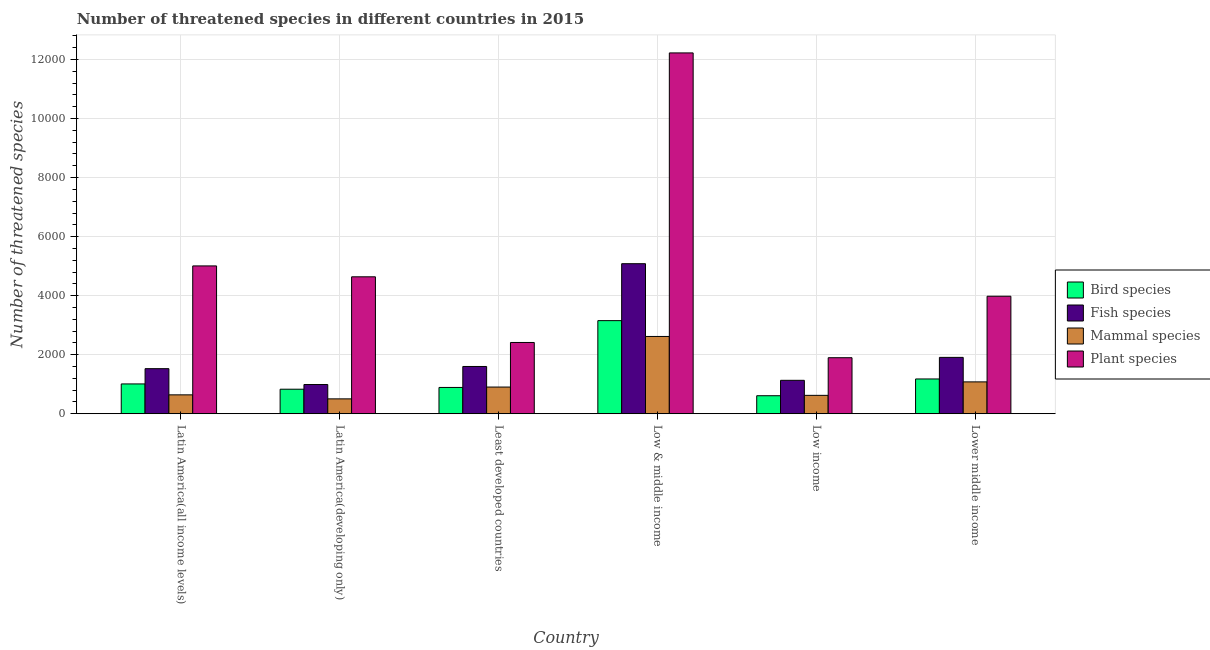How many groups of bars are there?
Your answer should be very brief. 6. Are the number of bars on each tick of the X-axis equal?
Your answer should be compact. Yes. What is the label of the 3rd group of bars from the left?
Keep it short and to the point. Least developed countries. What is the number of threatened plant species in Low & middle income?
Ensure brevity in your answer.  1.22e+04. Across all countries, what is the maximum number of threatened mammal species?
Provide a short and direct response. 2618. Across all countries, what is the minimum number of threatened mammal species?
Ensure brevity in your answer.  504. In which country was the number of threatened fish species maximum?
Your answer should be compact. Low & middle income. In which country was the number of threatened fish species minimum?
Give a very brief answer. Latin America(developing only). What is the total number of threatened fish species in the graph?
Offer a very short reply. 1.22e+04. What is the difference between the number of threatened bird species in Latin America(all income levels) and that in Latin America(developing only)?
Offer a very short reply. 179. What is the difference between the number of threatened plant species in Latin America(developing only) and the number of threatened fish species in Low income?
Offer a terse response. 3507. What is the average number of threatened bird species per country?
Provide a succinct answer. 1279. What is the difference between the number of threatened fish species and number of threatened mammal species in Low & middle income?
Provide a succinct answer. 2465. In how many countries, is the number of threatened mammal species greater than 2400 ?
Offer a terse response. 1. What is the ratio of the number of threatened mammal species in Least developed countries to that in Low income?
Your answer should be very brief. 1.45. Is the difference between the number of threatened plant species in Latin America(all income levels) and Least developed countries greater than the difference between the number of threatened fish species in Latin America(all income levels) and Least developed countries?
Make the answer very short. Yes. What is the difference between the highest and the second highest number of threatened mammal species?
Give a very brief answer. 1539. What is the difference between the highest and the lowest number of threatened mammal species?
Your response must be concise. 2114. In how many countries, is the number of threatened plant species greater than the average number of threatened plant species taken over all countries?
Offer a very short reply. 1. Is the sum of the number of threatened bird species in Latin America(all income levels) and Lower middle income greater than the maximum number of threatened fish species across all countries?
Your answer should be very brief. No. Is it the case that in every country, the sum of the number of threatened bird species and number of threatened mammal species is greater than the sum of number of threatened plant species and number of threatened fish species?
Provide a succinct answer. No. What does the 3rd bar from the left in Least developed countries represents?
Give a very brief answer. Mammal species. What does the 3rd bar from the right in Latin America(developing only) represents?
Offer a terse response. Fish species. Is it the case that in every country, the sum of the number of threatened bird species and number of threatened fish species is greater than the number of threatened mammal species?
Your response must be concise. Yes. How many countries are there in the graph?
Provide a short and direct response. 6. Are the values on the major ticks of Y-axis written in scientific E-notation?
Offer a terse response. No. Does the graph contain any zero values?
Give a very brief answer. No. Does the graph contain grids?
Your answer should be compact. Yes. How many legend labels are there?
Provide a succinct answer. 4. What is the title of the graph?
Offer a terse response. Number of threatened species in different countries in 2015. Does "Argument" appear as one of the legend labels in the graph?
Keep it short and to the point. No. What is the label or title of the X-axis?
Keep it short and to the point. Country. What is the label or title of the Y-axis?
Your answer should be very brief. Number of threatened species. What is the Number of threatened species of Bird species in Latin America(all income levels)?
Provide a succinct answer. 1010. What is the Number of threatened species in Fish species in Latin America(all income levels)?
Your answer should be very brief. 1527. What is the Number of threatened species of Mammal species in Latin America(all income levels)?
Your response must be concise. 640. What is the Number of threatened species in Plant species in Latin America(all income levels)?
Provide a succinct answer. 5008. What is the Number of threatened species in Bird species in Latin America(developing only)?
Provide a succinct answer. 831. What is the Number of threatened species of Fish species in Latin America(developing only)?
Offer a very short reply. 990. What is the Number of threatened species of Mammal species in Latin America(developing only)?
Your answer should be compact. 504. What is the Number of threatened species of Plant species in Latin America(developing only)?
Offer a terse response. 4639. What is the Number of threatened species in Bird species in Least developed countries?
Give a very brief answer. 891. What is the Number of threatened species of Fish species in Least developed countries?
Provide a succinct answer. 1601. What is the Number of threatened species in Mammal species in Least developed countries?
Make the answer very short. 904. What is the Number of threatened species in Plant species in Least developed countries?
Provide a short and direct response. 2414. What is the Number of threatened species in Bird species in Low & middle income?
Provide a short and direct response. 3154. What is the Number of threatened species of Fish species in Low & middle income?
Provide a succinct answer. 5083. What is the Number of threatened species of Mammal species in Low & middle income?
Keep it short and to the point. 2618. What is the Number of threatened species of Plant species in Low & middle income?
Provide a succinct answer. 1.22e+04. What is the Number of threatened species in Bird species in Low income?
Ensure brevity in your answer.  610. What is the Number of threatened species in Fish species in Low income?
Your answer should be compact. 1132. What is the Number of threatened species in Mammal species in Low income?
Ensure brevity in your answer.  623. What is the Number of threatened species of Plant species in Low income?
Ensure brevity in your answer.  1898. What is the Number of threatened species in Bird species in Lower middle income?
Give a very brief answer. 1178. What is the Number of threatened species in Fish species in Lower middle income?
Your response must be concise. 1909. What is the Number of threatened species of Mammal species in Lower middle income?
Your answer should be compact. 1079. What is the Number of threatened species in Plant species in Lower middle income?
Provide a short and direct response. 3981. Across all countries, what is the maximum Number of threatened species of Bird species?
Your response must be concise. 3154. Across all countries, what is the maximum Number of threatened species of Fish species?
Provide a succinct answer. 5083. Across all countries, what is the maximum Number of threatened species of Mammal species?
Make the answer very short. 2618. Across all countries, what is the maximum Number of threatened species in Plant species?
Offer a very short reply. 1.22e+04. Across all countries, what is the minimum Number of threatened species of Bird species?
Provide a succinct answer. 610. Across all countries, what is the minimum Number of threatened species of Fish species?
Your response must be concise. 990. Across all countries, what is the minimum Number of threatened species in Mammal species?
Ensure brevity in your answer.  504. Across all countries, what is the minimum Number of threatened species in Plant species?
Give a very brief answer. 1898. What is the total Number of threatened species in Bird species in the graph?
Provide a short and direct response. 7674. What is the total Number of threatened species in Fish species in the graph?
Your answer should be very brief. 1.22e+04. What is the total Number of threatened species of Mammal species in the graph?
Provide a short and direct response. 6368. What is the total Number of threatened species of Plant species in the graph?
Provide a short and direct response. 3.02e+04. What is the difference between the Number of threatened species of Bird species in Latin America(all income levels) and that in Latin America(developing only)?
Ensure brevity in your answer.  179. What is the difference between the Number of threatened species of Fish species in Latin America(all income levels) and that in Latin America(developing only)?
Offer a terse response. 537. What is the difference between the Number of threatened species in Mammal species in Latin America(all income levels) and that in Latin America(developing only)?
Provide a succinct answer. 136. What is the difference between the Number of threatened species of Plant species in Latin America(all income levels) and that in Latin America(developing only)?
Your response must be concise. 369. What is the difference between the Number of threatened species of Bird species in Latin America(all income levels) and that in Least developed countries?
Your answer should be compact. 119. What is the difference between the Number of threatened species of Fish species in Latin America(all income levels) and that in Least developed countries?
Provide a short and direct response. -74. What is the difference between the Number of threatened species of Mammal species in Latin America(all income levels) and that in Least developed countries?
Offer a terse response. -264. What is the difference between the Number of threatened species of Plant species in Latin America(all income levels) and that in Least developed countries?
Keep it short and to the point. 2594. What is the difference between the Number of threatened species in Bird species in Latin America(all income levels) and that in Low & middle income?
Your response must be concise. -2144. What is the difference between the Number of threatened species of Fish species in Latin America(all income levels) and that in Low & middle income?
Give a very brief answer. -3556. What is the difference between the Number of threatened species of Mammal species in Latin America(all income levels) and that in Low & middle income?
Offer a terse response. -1978. What is the difference between the Number of threatened species in Plant species in Latin America(all income levels) and that in Low & middle income?
Give a very brief answer. -7216. What is the difference between the Number of threatened species of Bird species in Latin America(all income levels) and that in Low income?
Offer a terse response. 400. What is the difference between the Number of threatened species in Fish species in Latin America(all income levels) and that in Low income?
Provide a succinct answer. 395. What is the difference between the Number of threatened species of Plant species in Latin America(all income levels) and that in Low income?
Provide a succinct answer. 3110. What is the difference between the Number of threatened species of Bird species in Latin America(all income levels) and that in Lower middle income?
Make the answer very short. -168. What is the difference between the Number of threatened species of Fish species in Latin America(all income levels) and that in Lower middle income?
Offer a very short reply. -382. What is the difference between the Number of threatened species of Mammal species in Latin America(all income levels) and that in Lower middle income?
Give a very brief answer. -439. What is the difference between the Number of threatened species of Plant species in Latin America(all income levels) and that in Lower middle income?
Make the answer very short. 1027. What is the difference between the Number of threatened species of Bird species in Latin America(developing only) and that in Least developed countries?
Provide a succinct answer. -60. What is the difference between the Number of threatened species of Fish species in Latin America(developing only) and that in Least developed countries?
Provide a short and direct response. -611. What is the difference between the Number of threatened species of Mammal species in Latin America(developing only) and that in Least developed countries?
Provide a succinct answer. -400. What is the difference between the Number of threatened species in Plant species in Latin America(developing only) and that in Least developed countries?
Provide a succinct answer. 2225. What is the difference between the Number of threatened species of Bird species in Latin America(developing only) and that in Low & middle income?
Offer a very short reply. -2323. What is the difference between the Number of threatened species in Fish species in Latin America(developing only) and that in Low & middle income?
Provide a short and direct response. -4093. What is the difference between the Number of threatened species of Mammal species in Latin America(developing only) and that in Low & middle income?
Give a very brief answer. -2114. What is the difference between the Number of threatened species of Plant species in Latin America(developing only) and that in Low & middle income?
Keep it short and to the point. -7585. What is the difference between the Number of threatened species of Bird species in Latin America(developing only) and that in Low income?
Your answer should be compact. 221. What is the difference between the Number of threatened species of Fish species in Latin America(developing only) and that in Low income?
Your answer should be compact. -142. What is the difference between the Number of threatened species of Mammal species in Latin America(developing only) and that in Low income?
Keep it short and to the point. -119. What is the difference between the Number of threatened species in Plant species in Latin America(developing only) and that in Low income?
Keep it short and to the point. 2741. What is the difference between the Number of threatened species in Bird species in Latin America(developing only) and that in Lower middle income?
Your answer should be very brief. -347. What is the difference between the Number of threatened species in Fish species in Latin America(developing only) and that in Lower middle income?
Your response must be concise. -919. What is the difference between the Number of threatened species in Mammal species in Latin America(developing only) and that in Lower middle income?
Your answer should be very brief. -575. What is the difference between the Number of threatened species in Plant species in Latin America(developing only) and that in Lower middle income?
Ensure brevity in your answer.  658. What is the difference between the Number of threatened species of Bird species in Least developed countries and that in Low & middle income?
Provide a succinct answer. -2263. What is the difference between the Number of threatened species of Fish species in Least developed countries and that in Low & middle income?
Provide a succinct answer. -3482. What is the difference between the Number of threatened species of Mammal species in Least developed countries and that in Low & middle income?
Provide a succinct answer. -1714. What is the difference between the Number of threatened species in Plant species in Least developed countries and that in Low & middle income?
Your answer should be very brief. -9810. What is the difference between the Number of threatened species of Bird species in Least developed countries and that in Low income?
Give a very brief answer. 281. What is the difference between the Number of threatened species in Fish species in Least developed countries and that in Low income?
Offer a very short reply. 469. What is the difference between the Number of threatened species of Mammal species in Least developed countries and that in Low income?
Ensure brevity in your answer.  281. What is the difference between the Number of threatened species in Plant species in Least developed countries and that in Low income?
Offer a very short reply. 516. What is the difference between the Number of threatened species in Bird species in Least developed countries and that in Lower middle income?
Offer a terse response. -287. What is the difference between the Number of threatened species in Fish species in Least developed countries and that in Lower middle income?
Keep it short and to the point. -308. What is the difference between the Number of threatened species of Mammal species in Least developed countries and that in Lower middle income?
Offer a very short reply. -175. What is the difference between the Number of threatened species in Plant species in Least developed countries and that in Lower middle income?
Provide a succinct answer. -1567. What is the difference between the Number of threatened species in Bird species in Low & middle income and that in Low income?
Ensure brevity in your answer.  2544. What is the difference between the Number of threatened species in Fish species in Low & middle income and that in Low income?
Keep it short and to the point. 3951. What is the difference between the Number of threatened species of Mammal species in Low & middle income and that in Low income?
Offer a very short reply. 1995. What is the difference between the Number of threatened species in Plant species in Low & middle income and that in Low income?
Your answer should be compact. 1.03e+04. What is the difference between the Number of threatened species in Bird species in Low & middle income and that in Lower middle income?
Your answer should be compact. 1976. What is the difference between the Number of threatened species in Fish species in Low & middle income and that in Lower middle income?
Ensure brevity in your answer.  3174. What is the difference between the Number of threatened species in Mammal species in Low & middle income and that in Lower middle income?
Ensure brevity in your answer.  1539. What is the difference between the Number of threatened species in Plant species in Low & middle income and that in Lower middle income?
Offer a terse response. 8243. What is the difference between the Number of threatened species of Bird species in Low income and that in Lower middle income?
Offer a very short reply. -568. What is the difference between the Number of threatened species of Fish species in Low income and that in Lower middle income?
Offer a very short reply. -777. What is the difference between the Number of threatened species in Mammal species in Low income and that in Lower middle income?
Offer a very short reply. -456. What is the difference between the Number of threatened species in Plant species in Low income and that in Lower middle income?
Offer a very short reply. -2083. What is the difference between the Number of threatened species in Bird species in Latin America(all income levels) and the Number of threatened species in Fish species in Latin America(developing only)?
Provide a short and direct response. 20. What is the difference between the Number of threatened species in Bird species in Latin America(all income levels) and the Number of threatened species in Mammal species in Latin America(developing only)?
Your answer should be compact. 506. What is the difference between the Number of threatened species in Bird species in Latin America(all income levels) and the Number of threatened species in Plant species in Latin America(developing only)?
Keep it short and to the point. -3629. What is the difference between the Number of threatened species in Fish species in Latin America(all income levels) and the Number of threatened species in Mammal species in Latin America(developing only)?
Your answer should be compact. 1023. What is the difference between the Number of threatened species in Fish species in Latin America(all income levels) and the Number of threatened species in Plant species in Latin America(developing only)?
Offer a terse response. -3112. What is the difference between the Number of threatened species of Mammal species in Latin America(all income levels) and the Number of threatened species of Plant species in Latin America(developing only)?
Your answer should be very brief. -3999. What is the difference between the Number of threatened species of Bird species in Latin America(all income levels) and the Number of threatened species of Fish species in Least developed countries?
Offer a terse response. -591. What is the difference between the Number of threatened species of Bird species in Latin America(all income levels) and the Number of threatened species of Mammal species in Least developed countries?
Keep it short and to the point. 106. What is the difference between the Number of threatened species in Bird species in Latin America(all income levels) and the Number of threatened species in Plant species in Least developed countries?
Give a very brief answer. -1404. What is the difference between the Number of threatened species of Fish species in Latin America(all income levels) and the Number of threatened species of Mammal species in Least developed countries?
Provide a succinct answer. 623. What is the difference between the Number of threatened species of Fish species in Latin America(all income levels) and the Number of threatened species of Plant species in Least developed countries?
Offer a very short reply. -887. What is the difference between the Number of threatened species in Mammal species in Latin America(all income levels) and the Number of threatened species in Plant species in Least developed countries?
Provide a succinct answer. -1774. What is the difference between the Number of threatened species of Bird species in Latin America(all income levels) and the Number of threatened species of Fish species in Low & middle income?
Offer a terse response. -4073. What is the difference between the Number of threatened species in Bird species in Latin America(all income levels) and the Number of threatened species in Mammal species in Low & middle income?
Offer a very short reply. -1608. What is the difference between the Number of threatened species of Bird species in Latin America(all income levels) and the Number of threatened species of Plant species in Low & middle income?
Your answer should be very brief. -1.12e+04. What is the difference between the Number of threatened species in Fish species in Latin America(all income levels) and the Number of threatened species in Mammal species in Low & middle income?
Provide a succinct answer. -1091. What is the difference between the Number of threatened species of Fish species in Latin America(all income levels) and the Number of threatened species of Plant species in Low & middle income?
Keep it short and to the point. -1.07e+04. What is the difference between the Number of threatened species in Mammal species in Latin America(all income levels) and the Number of threatened species in Plant species in Low & middle income?
Provide a short and direct response. -1.16e+04. What is the difference between the Number of threatened species of Bird species in Latin America(all income levels) and the Number of threatened species of Fish species in Low income?
Provide a short and direct response. -122. What is the difference between the Number of threatened species of Bird species in Latin America(all income levels) and the Number of threatened species of Mammal species in Low income?
Provide a succinct answer. 387. What is the difference between the Number of threatened species of Bird species in Latin America(all income levels) and the Number of threatened species of Plant species in Low income?
Provide a succinct answer. -888. What is the difference between the Number of threatened species in Fish species in Latin America(all income levels) and the Number of threatened species in Mammal species in Low income?
Provide a short and direct response. 904. What is the difference between the Number of threatened species in Fish species in Latin America(all income levels) and the Number of threatened species in Plant species in Low income?
Ensure brevity in your answer.  -371. What is the difference between the Number of threatened species of Mammal species in Latin America(all income levels) and the Number of threatened species of Plant species in Low income?
Provide a short and direct response. -1258. What is the difference between the Number of threatened species of Bird species in Latin America(all income levels) and the Number of threatened species of Fish species in Lower middle income?
Provide a succinct answer. -899. What is the difference between the Number of threatened species in Bird species in Latin America(all income levels) and the Number of threatened species in Mammal species in Lower middle income?
Your answer should be very brief. -69. What is the difference between the Number of threatened species of Bird species in Latin America(all income levels) and the Number of threatened species of Plant species in Lower middle income?
Provide a short and direct response. -2971. What is the difference between the Number of threatened species of Fish species in Latin America(all income levels) and the Number of threatened species of Mammal species in Lower middle income?
Keep it short and to the point. 448. What is the difference between the Number of threatened species in Fish species in Latin America(all income levels) and the Number of threatened species in Plant species in Lower middle income?
Your response must be concise. -2454. What is the difference between the Number of threatened species of Mammal species in Latin America(all income levels) and the Number of threatened species of Plant species in Lower middle income?
Provide a short and direct response. -3341. What is the difference between the Number of threatened species in Bird species in Latin America(developing only) and the Number of threatened species in Fish species in Least developed countries?
Offer a very short reply. -770. What is the difference between the Number of threatened species of Bird species in Latin America(developing only) and the Number of threatened species of Mammal species in Least developed countries?
Ensure brevity in your answer.  -73. What is the difference between the Number of threatened species in Bird species in Latin America(developing only) and the Number of threatened species in Plant species in Least developed countries?
Your answer should be compact. -1583. What is the difference between the Number of threatened species in Fish species in Latin America(developing only) and the Number of threatened species in Mammal species in Least developed countries?
Make the answer very short. 86. What is the difference between the Number of threatened species in Fish species in Latin America(developing only) and the Number of threatened species in Plant species in Least developed countries?
Give a very brief answer. -1424. What is the difference between the Number of threatened species of Mammal species in Latin America(developing only) and the Number of threatened species of Plant species in Least developed countries?
Provide a succinct answer. -1910. What is the difference between the Number of threatened species in Bird species in Latin America(developing only) and the Number of threatened species in Fish species in Low & middle income?
Ensure brevity in your answer.  -4252. What is the difference between the Number of threatened species in Bird species in Latin America(developing only) and the Number of threatened species in Mammal species in Low & middle income?
Provide a short and direct response. -1787. What is the difference between the Number of threatened species of Bird species in Latin America(developing only) and the Number of threatened species of Plant species in Low & middle income?
Provide a succinct answer. -1.14e+04. What is the difference between the Number of threatened species of Fish species in Latin America(developing only) and the Number of threatened species of Mammal species in Low & middle income?
Provide a succinct answer. -1628. What is the difference between the Number of threatened species in Fish species in Latin America(developing only) and the Number of threatened species in Plant species in Low & middle income?
Provide a succinct answer. -1.12e+04. What is the difference between the Number of threatened species in Mammal species in Latin America(developing only) and the Number of threatened species in Plant species in Low & middle income?
Your response must be concise. -1.17e+04. What is the difference between the Number of threatened species of Bird species in Latin America(developing only) and the Number of threatened species of Fish species in Low income?
Your response must be concise. -301. What is the difference between the Number of threatened species of Bird species in Latin America(developing only) and the Number of threatened species of Mammal species in Low income?
Ensure brevity in your answer.  208. What is the difference between the Number of threatened species of Bird species in Latin America(developing only) and the Number of threatened species of Plant species in Low income?
Ensure brevity in your answer.  -1067. What is the difference between the Number of threatened species in Fish species in Latin America(developing only) and the Number of threatened species in Mammal species in Low income?
Provide a succinct answer. 367. What is the difference between the Number of threatened species of Fish species in Latin America(developing only) and the Number of threatened species of Plant species in Low income?
Give a very brief answer. -908. What is the difference between the Number of threatened species in Mammal species in Latin America(developing only) and the Number of threatened species in Plant species in Low income?
Ensure brevity in your answer.  -1394. What is the difference between the Number of threatened species in Bird species in Latin America(developing only) and the Number of threatened species in Fish species in Lower middle income?
Your response must be concise. -1078. What is the difference between the Number of threatened species in Bird species in Latin America(developing only) and the Number of threatened species in Mammal species in Lower middle income?
Give a very brief answer. -248. What is the difference between the Number of threatened species of Bird species in Latin America(developing only) and the Number of threatened species of Plant species in Lower middle income?
Keep it short and to the point. -3150. What is the difference between the Number of threatened species in Fish species in Latin America(developing only) and the Number of threatened species in Mammal species in Lower middle income?
Provide a short and direct response. -89. What is the difference between the Number of threatened species in Fish species in Latin America(developing only) and the Number of threatened species in Plant species in Lower middle income?
Provide a succinct answer. -2991. What is the difference between the Number of threatened species of Mammal species in Latin America(developing only) and the Number of threatened species of Plant species in Lower middle income?
Offer a terse response. -3477. What is the difference between the Number of threatened species in Bird species in Least developed countries and the Number of threatened species in Fish species in Low & middle income?
Provide a succinct answer. -4192. What is the difference between the Number of threatened species in Bird species in Least developed countries and the Number of threatened species in Mammal species in Low & middle income?
Give a very brief answer. -1727. What is the difference between the Number of threatened species of Bird species in Least developed countries and the Number of threatened species of Plant species in Low & middle income?
Offer a terse response. -1.13e+04. What is the difference between the Number of threatened species in Fish species in Least developed countries and the Number of threatened species in Mammal species in Low & middle income?
Give a very brief answer. -1017. What is the difference between the Number of threatened species of Fish species in Least developed countries and the Number of threatened species of Plant species in Low & middle income?
Give a very brief answer. -1.06e+04. What is the difference between the Number of threatened species of Mammal species in Least developed countries and the Number of threatened species of Plant species in Low & middle income?
Provide a short and direct response. -1.13e+04. What is the difference between the Number of threatened species of Bird species in Least developed countries and the Number of threatened species of Fish species in Low income?
Your answer should be very brief. -241. What is the difference between the Number of threatened species of Bird species in Least developed countries and the Number of threatened species of Mammal species in Low income?
Offer a very short reply. 268. What is the difference between the Number of threatened species of Bird species in Least developed countries and the Number of threatened species of Plant species in Low income?
Provide a succinct answer. -1007. What is the difference between the Number of threatened species of Fish species in Least developed countries and the Number of threatened species of Mammal species in Low income?
Provide a short and direct response. 978. What is the difference between the Number of threatened species in Fish species in Least developed countries and the Number of threatened species in Plant species in Low income?
Provide a succinct answer. -297. What is the difference between the Number of threatened species in Mammal species in Least developed countries and the Number of threatened species in Plant species in Low income?
Make the answer very short. -994. What is the difference between the Number of threatened species of Bird species in Least developed countries and the Number of threatened species of Fish species in Lower middle income?
Offer a terse response. -1018. What is the difference between the Number of threatened species in Bird species in Least developed countries and the Number of threatened species in Mammal species in Lower middle income?
Provide a succinct answer. -188. What is the difference between the Number of threatened species of Bird species in Least developed countries and the Number of threatened species of Plant species in Lower middle income?
Ensure brevity in your answer.  -3090. What is the difference between the Number of threatened species in Fish species in Least developed countries and the Number of threatened species in Mammal species in Lower middle income?
Offer a very short reply. 522. What is the difference between the Number of threatened species of Fish species in Least developed countries and the Number of threatened species of Plant species in Lower middle income?
Your answer should be compact. -2380. What is the difference between the Number of threatened species of Mammal species in Least developed countries and the Number of threatened species of Plant species in Lower middle income?
Offer a terse response. -3077. What is the difference between the Number of threatened species in Bird species in Low & middle income and the Number of threatened species in Fish species in Low income?
Your response must be concise. 2022. What is the difference between the Number of threatened species in Bird species in Low & middle income and the Number of threatened species in Mammal species in Low income?
Ensure brevity in your answer.  2531. What is the difference between the Number of threatened species of Bird species in Low & middle income and the Number of threatened species of Plant species in Low income?
Provide a short and direct response. 1256. What is the difference between the Number of threatened species of Fish species in Low & middle income and the Number of threatened species of Mammal species in Low income?
Keep it short and to the point. 4460. What is the difference between the Number of threatened species in Fish species in Low & middle income and the Number of threatened species in Plant species in Low income?
Your answer should be very brief. 3185. What is the difference between the Number of threatened species of Mammal species in Low & middle income and the Number of threatened species of Plant species in Low income?
Give a very brief answer. 720. What is the difference between the Number of threatened species of Bird species in Low & middle income and the Number of threatened species of Fish species in Lower middle income?
Make the answer very short. 1245. What is the difference between the Number of threatened species in Bird species in Low & middle income and the Number of threatened species in Mammal species in Lower middle income?
Your answer should be very brief. 2075. What is the difference between the Number of threatened species of Bird species in Low & middle income and the Number of threatened species of Plant species in Lower middle income?
Ensure brevity in your answer.  -827. What is the difference between the Number of threatened species in Fish species in Low & middle income and the Number of threatened species in Mammal species in Lower middle income?
Offer a very short reply. 4004. What is the difference between the Number of threatened species in Fish species in Low & middle income and the Number of threatened species in Plant species in Lower middle income?
Provide a succinct answer. 1102. What is the difference between the Number of threatened species of Mammal species in Low & middle income and the Number of threatened species of Plant species in Lower middle income?
Your response must be concise. -1363. What is the difference between the Number of threatened species of Bird species in Low income and the Number of threatened species of Fish species in Lower middle income?
Make the answer very short. -1299. What is the difference between the Number of threatened species in Bird species in Low income and the Number of threatened species in Mammal species in Lower middle income?
Provide a short and direct response. -469. What is the difference between the Number of threatened species of Bird species in Low income and the Number of threatened species of Plant species in Lower middle income?
Your answer should be very brief. -3371. What is the difference between the Number of threatened species of Fish species in Low income and the Number of threatened species of Plant species in Lower middle income?
Keep it short and to the point. -2849. What is the difference between the Number of threatened species in Mammal species in Low income and the Number of threatened species in Plant species in Lower middle income?
Your answer should be compact. -3358. What is the average Number of threatened species in Bird species per country?
Keep it short and to the point. 1279. What is the average Number of threatened species in Fish species per country?
Your answer should be compact. 2040.33. What is the average Number of threatened species of Mammal species per country?
Ensure brevity in your answer.  1061.33. What is the average Number of threatened species of Plant species per country?
Give a very brief answer. 5027.33. What is the difference between the Number of threatened species in Bird species and Number of threatened species in Fish species in Latin America(all income levels)?
Your response must be concise. -517. What is the difference between the Number of threatened species in Bird species and Number of threatened species in Mammal species in Latin America(all income levels)?
Your answer should be very brief. 370. What is the difference between the Number of threatened species of Bird species and Number of threatened species of Plant species in Latin America(all income levels)?
Keep it short and to the point. -3998. What is the difference between the Number of threatened species of Fish species and Number of threatened species of Mammal species in Latin America(all income levels)?
Provide a short and direct response. 887. What is the difference between the Number of threatened species in Fish species and Number of threatened species in Plant species in Latin America(all income levels)?
Provide a short and direct response. -3481. What is the difference between the Number of threatened species in Mammal species and Number of threatened species in Plant species in Latin America(all income levels)?
Give a very brief answer. -4368. What is the difference between the Number of threatened species of Bird species and Number of threatened species of Fish species in Latin America(developing only)?
Offer a terse response. -159. What is the difference between the Number of threatened species of Bird species and Number of threatened species of Mammal species in Latin America(developing only)?
Your answer should be very brief. 327. What is the difference between the Number of threatened species of Bird species and Number of threatened species of Plant species in Latin America(developing only)?
Provide a succinct answer. -3808. What is the difference between the Number of threatened species of Fish species and Number of threatened species of Mammal species in Latin America(developing only)?
Your answer should be compact. 486. What is the difference between the Number of threatened species of Fish species and Number of threatened species of Plant species in Latin America(developing only)?
Offer a very short reply. -3649. What is the difference between the Number of threatened species of Mammal species and Number of threatened species of Plant species in Latin America(developing only)?
Your response must be concise. -4135. What is the difference between the Number of threatened species of Bird species and Number of threatened species of Fish species in Least developed countries?
Give a very brief answer. -710. What is the difference between the Number of threatened species of Bird species and Number of threatened species of Plant species in Least developed countries?
Make the answer very short. -1523. What is the difference between the Number of threatened species in Fish species and Number of threatened species in Mammal species in Least developed countries?
Your response must be concise. 697. What is the difference between the Number of threatened species of Fish species and Number of threatened species of Plant species in Least developed countries?
Your answer should be very brief. -813. What is the difference between the Number of threatened species of Mammal species and Number of threatened species of Plant species in Least developed countries?
Your answer should be very brief. -1510. What is the difference between the Number of threatened species in Bird species and Number of threatened species in Fish species in Low & middle income?
Your response must be concise. -1929. What is the difference between the Number of threatened species in Bird species and Number of threatened species in Mammal species in Low & middle income?
Make the answer very short. 536. What is the difference between the Number of threatened species of Bird species and Number of threatened species of Plant species in Low & middle income?
Provide a short and direct response. -9070. What is the difference between the Number of threatened species in Fish species and Number of threatened species in Mammal species in Low & middle income?
Provide a short and direct response. 2465. What is the difference between the Number of threatened species in Fish species and Number of threatened species in Plant species in Low & middle income?
Give a very brief answer. -7141. What is the difference between the Number of threatened species in Mammal species and Number of threatened species in Plant species in Low & middle income?
Offer a very short reply. -9606. What is the difference between the Number of threatened species in Bird species and Number of threatened species in Fish species in Low income?
Give a very brief answer. -522. What is the difference between the Number of threatened species in Bird species and Number of threatened species in Plant species in Low income?
Keep it short and to the point. -1288. What is the difference between the Number of threatened species in Fish species and Number of threatened species in Mammal species in Low income?
Give a very brief answer. 509. What is the difference between the Number of threatened species in Fish species and Number of threatened species in Plant species in Low income?
Provide a succinct answer. -766. What is the difference between the Number of threatened species in Mammal species and Number of threatened species in Plant species in Low income?
Provide a succinct answer. -1275. What is the difference between the Number of threatened species in Bird species and Number of threatened species in Fish species in Lower middle income?
Your response must be concise. -731. What is the difference between the Number of threatened species in Bird species and Number of threatened species in Mammal species in Lower middle income?
Offer a terse response. 99. What is the difference between the Number of threatened species of Bird species and Number of threatened species of Plant species in Lower middle income?
Give a very brief answer. -2803. What is the difference between the Number of threatened species in Fish species and Number of threatened species in Mammal species in Lower middle income?
Your answer should be very brief. 830. What is the difference between the Number of threatened species of Fish species and Number of threatened species of Plant species in Lower middle income?
Provide a succinct answer. -2072. What is the difference between the Number of threatened species of Mammal species and Number of threatened species of Plant species in Lower middle income?
Your answer should be compact. -2902. What is the ratio of the Number of threatened species in Bird species in Latin America(all income levels) to that in Latin America(developing only)?
Your answer should be very brief. 1.22. What is the ratio of the Number of threatened species of Fish species in Latin America(all income levels) to that in Latin America(developing only)?
Make the answer very short. 1.54. What is the ratio of the Number of threatened species of Mammal species in Latin America(all income levels) to that in Latin America(developing only)?
Provide a short and direct response. 1.27. What is the ratio of the Number of threatened species of Plant species in Latin America(all income levels) to that in Latin America(developing only)?
Your response must be concise. 1.08. What is the ratio of the Number of threatened species in Bird species in Latin America(all income levels) to that in Least developed countries?
Your answer should be compact. 1.13. What is the ratio of the Number of threatened species of Fish species in Latin America(all income levels) to that in Least developed countries?
Provide a short and direct response. 0.95. What is the ratio of the Number of threatened species in Mammal species in Latin America(all income levels) to that in Least developed countries?
Your answer should be compact. 0.71. What is the ratio of the Number of threatened species in Plant species in Latin America(all income levels) to that in Least developed countries?
Your answer should be very brief. 2.07. What is the ratio of the Number of threatened species in Bird species in Latin America(all income levels) to that in Low & middle income?
Your answer should be very brief. 0.32. What is the ratio of the Number of threatened species in Fish species in Latin America(all income levels) to that in Low & middle income?
Provide a succinct answer. 0.3. What is the ratio of the Number of threatened species of Mammal species in Latin America(all income levels) to that in Low & middle income?
Your answer should be very brief. 0.24. What is the ratio of the Number of threatened species in Plant species in Latin America(all income levels) to that in Low & middle income?
Ensure brevity in your answer.  0.41. What is the ratio of the Number of threatened species of Bird species in Latin America(all income levels) to that in Low income?
Provide a short and direct response. 1.66. What is the ratio of the Number of threatened species in Fish species in Latin America(all income levels) to that in Low income?
Offer a terse response. 1.35. What is the ratio of the Number of threatened species of Mammal species in Latin America(all income levels) to that in Low income?
Keep it short and to the point. 1.03. What is the ratio of the Number of threatened species of Plant species in Latin America(all income levels) to that in Low income?
Keep it short and to the point. 2.64. What is the ratio of the Number of threatened species in Bird species in Latin America(all income levels) to that in Lower middle income?
Give a very brief answer. 0.86. What is the ratio of the Number of threatened species of Fish species in Latin America(all income levels) to that in Lower middle income?
Provide a succinct answer. 0.8. What is the ratio of the Number of threatened species in Mammal species in Latin America(all income levels) to that in Lower middle income?
Ensure brevity in your answer.  0.59. What is the ratio of the Number of threatened species in Plant species in Latin America(all income levels) to that in Lower middle income?
Ensure brevity in your answer.  1.26. What is the ratio of the Number of threatened species in Bird species in Latin America(developing only) to that in Least developed countries?
Offer a very short reply. 0.93. What is the ratio of the Number of threatened species in Fish species in Latin America(developing only) to that in Least developed countries?
Your response must be concise. 0.62. What is the ratio of the Number of threatened species of Mammal species in Latin America(developing only) to that in Least developed countries?
Offer a very short reply. 0.56. What is the ratio of the Number of threatened species in Plant species in Latin America(developing only) to that in Least developed countries?
Offer a terse response. 1.92. What is the ratio of the Number of threatened species of Bird species in Latin America(developing only) to that in Low & middle income?
Your answer should be very brief. 0.26. What is the ratio of the Number of threatened species in Fish species in Latin America(developing only) to that in Low & middle income?
Your answer should be very brief. 0.19. What is the ratio of the Number of threatened species in Mammal species in Latin America(developing only) to that in Low & middle income?
Provide a succinct answer. 0.19. What is the ratio of the Number of threatened species of Plant species in Latin America(developing only) to that in Low & middle income?
Give a very brief answer. 0.38. What is the ratio of the Number of threatened species in Bird species in Latin America(developing only) to that in Low income?
Your answer should be compact. 1.36. What is the ratio of the Number of threatened species of Fish species in Latin America(developing only) to that in Low income?
Provide a succinct answer. 0.87. What is the ratio of the Number of threatened species in Mammal species in Latin America(developing only) to that in Low income?
Your response must be concise. 0.81. What is the ratio of the Number of threatened species of Plant species in Latin America(developing only) to that in Low income?
Make the answer very short. 2.44. What is the ratio of the Number of threatened species in Bird species in Latin America(developing only) to that in Lower middle income?
Your response must be concise. 0.71. What is the ratio of the Number of threatened species of Fish species in Latin America(developing only) to that in Lower middle income?
Give a very brief answer. 0.52. What is the ratio of the Number of threatened species of Mammal species in Latin America(developing only) to that in Lower middle income?
Offer a very short reply. 0.47. What is the ratio of the Number of threatened species of Plant species in Latin America(developing only) to that in Lower middle income?
Provide a succinct answer. 1.17. What is the ratio of the Number of threatened species in Bird species in Least developed countries to that in Low & middle income?
Your answer should be very brief. 0.28. What is the ratio of the Number of threatened species of Fish species in Least developed countries to that in Low & middle income?
Ensure brevity in your answer.  0.32. What is the ratio of the Number of threatened species of Mammal species in Least developed countries to that in Low & middle income?
Your answer should be compact. 0.35. What is the ratio of the Number of threatened species in Plant species in Least developed countries to that in Low & middle income?
Offer a very short reply. 0.2. What is the ratio of the Number of threatened species of Bird species in Least developed countries to that in Low income?
Provide a succinct answer. 1.46. What is the ratio of the Number of threatened species in Fish species in Least developed countries to that in Low income?
Your answer should be very brief. 1.41. What is the ratio of the Number of threatened species of Mammal species in Least developed countries to that in Low income?
Your answer should be very brief. 1.45. What is the ratio of the Number of threatened species in Plant species in Least developed countries to that in Low income?
Your answer should be very brief. 1.27. What is the ratio of the Number of threatened species of Bird species in Least developed countries to that in Lower middle income?
Offer a very short reply. 0.76. What is the ratio of the Number of threatened species in Fish species in Least developed countries to that in Lower middle income?
Give a very brief answer. 0.84. What is the ratio of the Number of threatened species in Mammal species in Least developed countries to that in Lower middle income?
Provide a short and direct response. 0.84. What is the ratio of the Number of threatened species in Plant species in Least developed countries to that in Lower middle income?
Your answer should be very brief. 0.61. What is the ratio of the Number of threatened species in Bird species in Low & middle income to that in Low income?
Offer a terse response. 5.17. What is the ratio of the Number of threatened species in Fish species in Low & middle income to that in Low income?
Make the answer very short. 4.49. What is the ratio of the Number of threatened species of Mammal species in Low & middle income to that in Low income?
Your response must be concise. 4.2. What is the ratio of the Number of threatened species of Plant species in Low & middle income to that in Low income?
Keep it short and to the point. 6.44. What is the ratio of the Number of threatened species in Bird species in Low & middle income to that in Lower middle income?
Your response must be concise. 2.68. What is the ratio of the Number of threatened species of Fish species in Low & middle income to that in Lower middle income?
Keep it short and to the point. 2.66. What is the ratio of the Number of threatened species of Mammal species in Low & middle income to that in Lower middle income?
Give a very brief answer. 2.43. What is the ratio of the Number of threatened species of Plant species in Low & middle income to that in Lower middle income?
Your answer should be very brief. 3.07. What is the ratio of the Number of threatened species of Bird species in Low income to that in Lower middle income?
Make the answer very short. 0.52. What is the ratio of the Number of threatened species of Fish species in Low income to that in Lower middle income?
Provide a short and direct response. 0.59. What is the ratio of the Number of threatened species of Mammal species in Low income to that in Lower middle income?
Your answer should be compact. 0.58. What is the ratio of the Number of threatened species in Plant species in Low income to that in Lower middle income?
Provide a short and direct response. 0.48. What is the difference between the highest and the second highest Number of threatened species of Bird species?
Your answer should be compact. 1976. What is the difference between the highest and the second highest Number of threatened species of Fish species?
Your answer should be compact. 3174. What is the difference between the highest and the second highest Number of threatened species of Mammal species?
Offer a very short reply. 1539. What is the difference between the highest and the second highest Number of threatened species in Plant species?
Your answer should be compact. 7216. What is the difference between the highest and the lowest Number of threatened species of Bird species?
Make the answer very short. 2544. What is the difference between the highest and the lowest Number of threatened species of Fish species?
Your answer should be compact. 4093. What is the difference between the highest and the lowest Number of threatened species in Mammal species?
Provide a short and direct response. 2114. What is the difference between the highest and the lowest Number of threatened species of Plant species?
Give a very brief answer. 1.03e+04. 